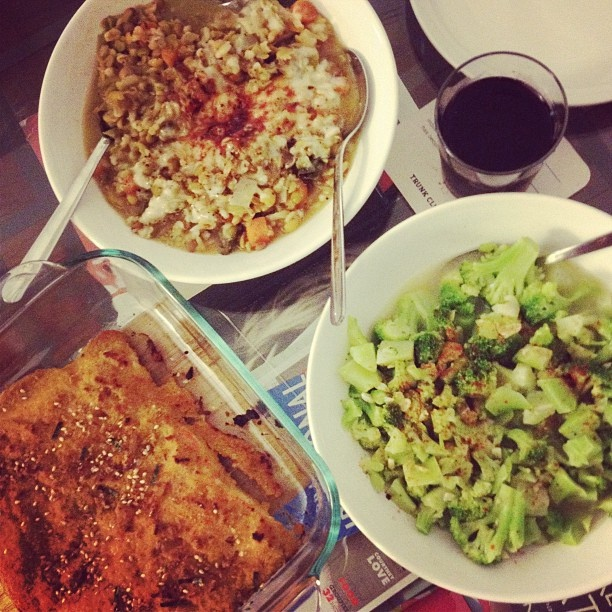Describe the objects in this image and their specific colors. I can see bowl in purple, beige, and olive tones, bowl in purple, brown, and tan tones, broccoli in purple, olive, khaki, and maroon tones, dining table in purple, black, and brown tones, and cup in purple, black, tan, and brown tones in this image. 